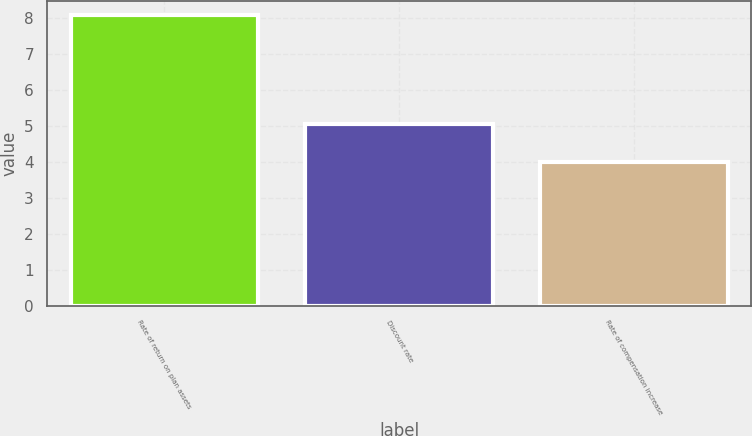Convert chart to OTSL. <chart><loc_0><loc_0><loc_500><loc_500><bar_chart><fcel>Rate of return on plan assets<fcel>Discount rate<fcel>Rate of compensation increase<nl><fcel>8.08<fcel>5.07<fcel>4<nl></chart> 